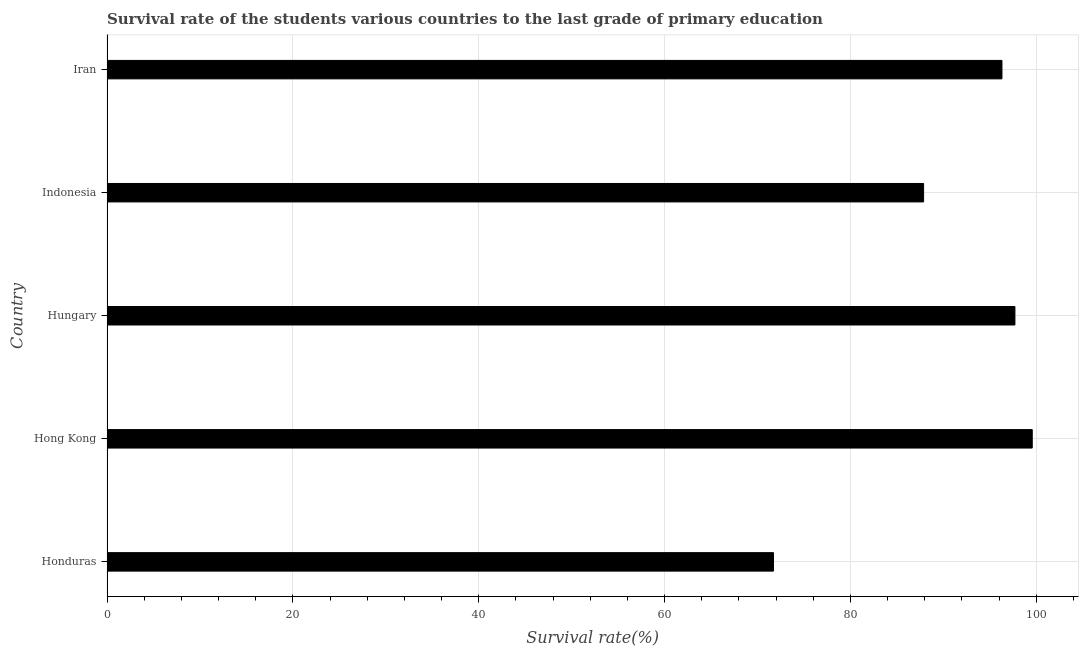Does the graph contain any zero values?
Offer a very short reply. No. Does the graph contain grids?
Your response must be concise. Yes. What is the title of the graph?
Provide a succinct answer. Survival rate of the students various countries to the last grade of primary education. What is the label or title of the X-axis?
Offer a terse response. Survival rate(%). What is the label or title of the Y-axis?
Your response must be concise. Country. What is the survival rate in primary education in Indonesia?
Keep it short and to the point. 87.87. Across all countries, what is the maximum survival rate in primary education?
Your response must be concise. 99.56. Across all countries, what is the minimum survival rate in primary education?
Ensure brevity in your answer.  71.72. In which country was the survival rate in primary education maximum?
Your answer should be very brief. Hong Kong. In which country was the survival rate in primary education minimum?
Your response must be concise. Honduras. What is the sum of the survival rate in primary education?
Your answer should be compact. 453.15. What is the difference between the survival rate in primary education in Honduras and Hungary?
Offer a very short reply. -25.98. What is the average survival rate in primary education per country?
Offer a terse response. 90.63. What is the median survival rate in primary education?
Keep it short and to the point. 96.3. What is the ratio of the survival rate in primary education in Honduras to that in Indonesia?
Make the answer very short. 0.82. Is the survival rate in primary education in Hong Kong less than that in Hungary?
Give a very brief answer. No. What is the difference between the highest and the second highest survival rate in primary education?
Your answer should be very brief. 1.86. Is the sum of the survival rate in primary education in Hong Kong and Hungary greater than the maximum survival rate in primary education across all countries?
Make the answer very short. Yes. What is the difference between the highest and the lowest survival rate in primary education?
Your answer should be very brief. 27.84. Are all the bars in the graph horizontal?
Make the answer very short. Yes. How many countries are there in the graph?
Offer a terse response. 5. What is the difference between two consecutive major ticks on the X-axis?
Your response must be concise. 20. Are the values on the major ticks of X-axis written in scientific E-notation?
Provide a succinct answer. No. What is the Survival rate(%) of Honduras?
Your response must be concise. 71.72. What is the Survival rate(%) in Hong Kong?
Provide a succinct answer. 99.56. What is the Survival rate(%) in Hungary?
Offer a very short reply. 97.7. What is the Survival rate(%) in Indonesia?
Keep it short and to the point. 87.87. What is the Survival rate(%) in Iran?
Your response must be concise. 96.3. What is the difference between the Survival rate(%) in Honduras and Hong Kong?
Your response must be concise. -27.84. What is the difference between the Survival rate(%) in Honduras and Hungary?
Ensure brevity in your answer.  -25.98. What is the difference between the Survival rate(%) in Honduras and Indonesia?
Keep it short and to the point. -16.15. What is the difference between the Survival rate(%) in Honduras and Iran?
Offer a very short reply. -24.59. What is the difference between the Survival rate(%) in Hong Kong and Hungary?
Ensure brevity in your answer.  1.86. What is the difference between the Survival rate(%) in Hong Kong and Indonesia?
Your response must be concise. 11.69. What is the difference between the Survival rate(%) in Hong Kong and Iran?
Your answer should be compact. 3.26. What is the difference between the Survival rate(%) in Hungary and Indonesia?
Provide a short and direct response. 9.83. What is the difference between the Survival rate(%) in Hungary and Iran?
Offer a terse response. 1.4. What is the difference between the Survival rate(%) in Indonesia and Iran?
Your response must be concise. -8.43. What is the ratio of the Survival rate(%) in Honduras to that in Hong Kong?
Keep it short and to the point. 0.72. What is the ratio of the Survival rate(%) in Honduras to that in Hungary?
Your response must be concise. 0.73. What is the ratio of the Survival rate(%) in Honduras to that in Indonesia?
Make the answer very short. 0.82. What is the ratio of the Survival rate(%) in Honduras to that in Iran?
Provide a succinct answer. 0.74. What is the ratio of the Survival rate(%) in Hong Kong to that in Indonesia?
Your answer should be compact. 1.13. What is the ratio of the Survival rate(%) in Hong Kong to that in Iran?
Your response must be concise. 1.03. What is the ratio of the Survival rate(%) in Hungary to that in Indonesia?
Provide a succinct answer. 1.11. What is the ratio of the Survival rate(%) in Hungary to that in Iran?
Ensure brevity in your answer.  1.01. What is the ratio of the Survival rate(%) in Indonesia to that in Iran?
Your answer should be very brief. 0.91. 